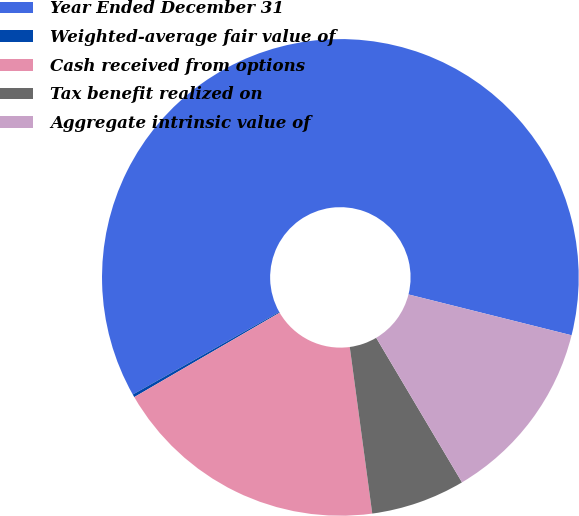Convert chart. <chart><loc_0><loc_0><loc_500><loc_500><pie_chart><fcel>Year Ended December 31<fcel>Weighted-average fair value of<fcel>Cash received from options<fcel>Tax benefit realized on<fcel>Aggregate intrinsic value of<nl><fcel>62.08%<fcel>0.2%<fcel>18.76%<fcel>6.39%<fcel>12.57%<nl></chart> 